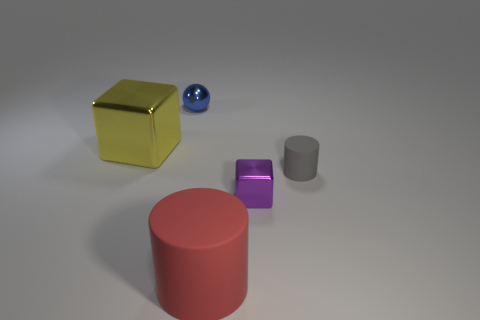Is the shape of the large rubber object that is in front of the small blue metal object the same as the metallic thing in front of the yellow cube?
Ensure brevity in your answer.  No. Does the small block have the same material as the big cube?
Provide a short and direct response. Yes. Is there anything else that has the same shape as the blue metallic object?
Make the answer very short. No. There is a block that is on the left side of the object that is behind the yellow block; what is its material?
Offer a terse response. Metal. There is a cylinder that is right of the tiny purple metallic object; what size is it?
Your answer should be compact. Small. What is the color of the small thing that is left of the gray matte thing and on the right side of the tiny blue object?
Ensure brevity in your answer.  Purple. There is a matte cylinder to the left of the gray matte cylinder; is it the same size as the small gray cylinder?
Provide a short and direct response. No. Is there a thing that is in front of the metallic cube that is in front of the small rubber cylinder?
Offer a terse response. Yes. What is the large cylinder made of?
Offer a terse response. Rubber. Are there any things in front of the ball?
Your answer should be very brief. Yes. 